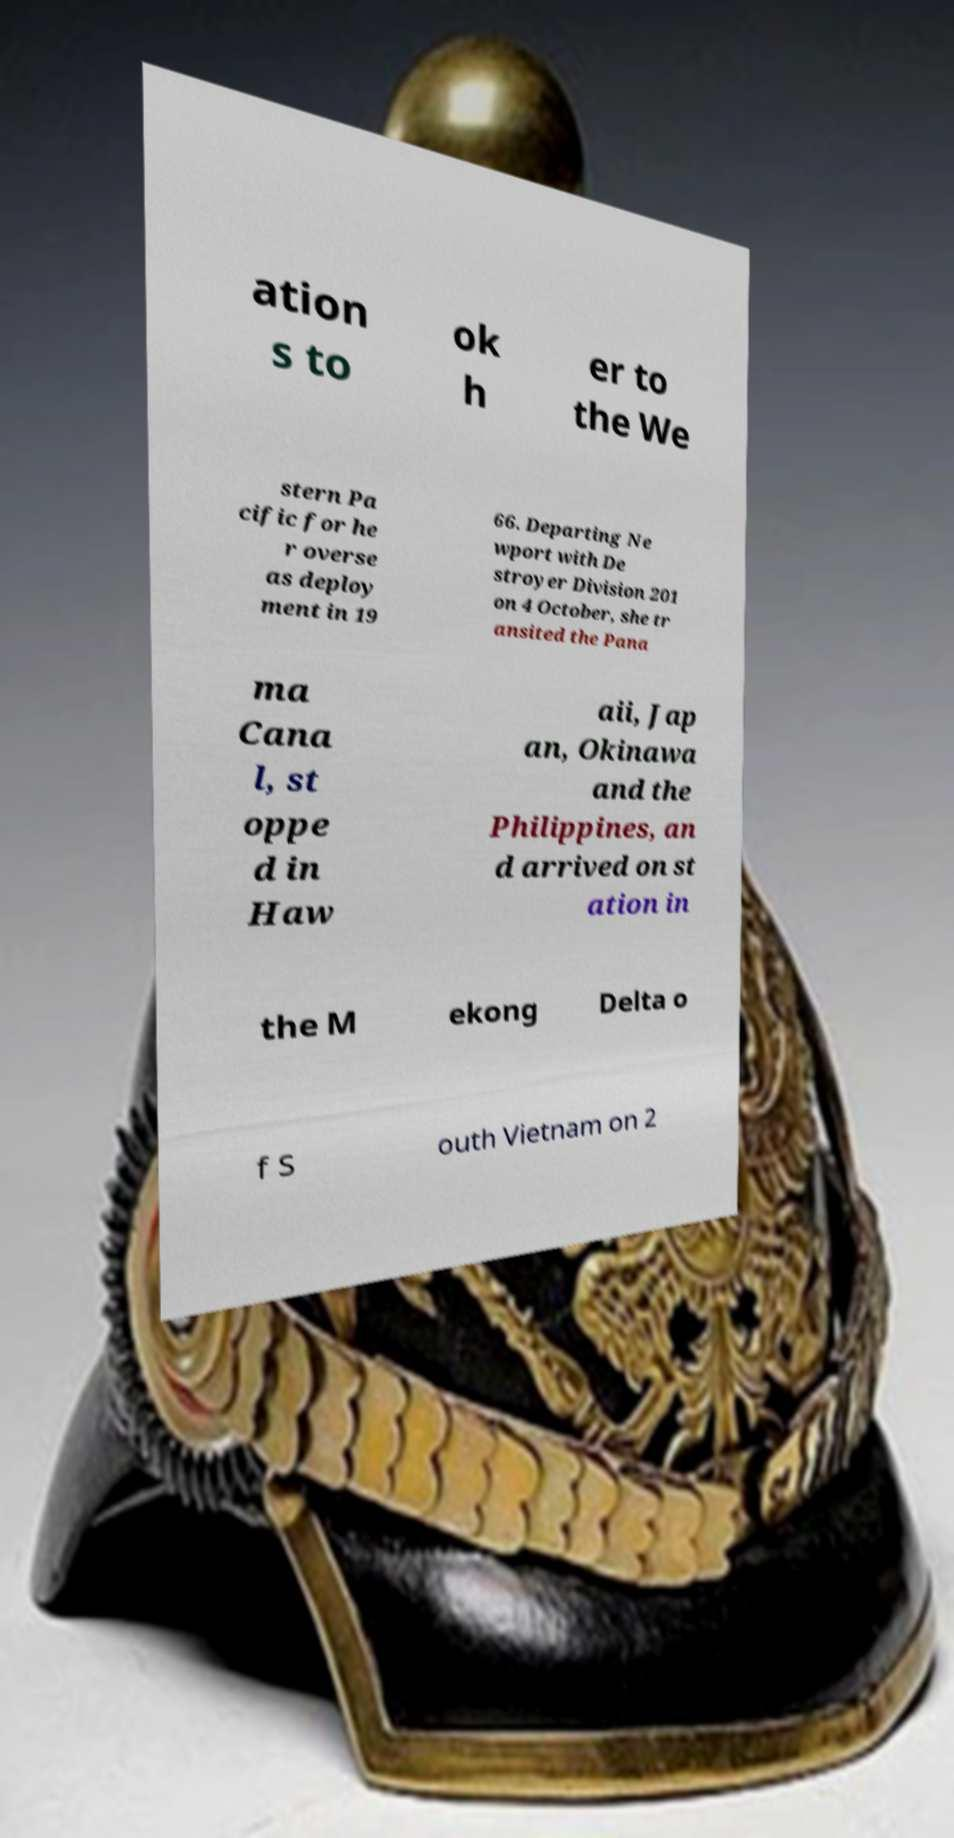Can you read and provide the text displayed in the image?This photo seems to have some interesting text. Can you extract and type it out for me? ation s to ok h er to the We stern Pa cific for he r overse as deploy ment in 19 66. Departing Ne wport with De stroyer Division 201 on 4 October, she tr ansited the Pana ma Cana l, st oppe d in Haw aii, Jap an, Okinawa and the Philippines, an d arrived on st ation in the M ekong Delta o f S outh Vietnam on 2 